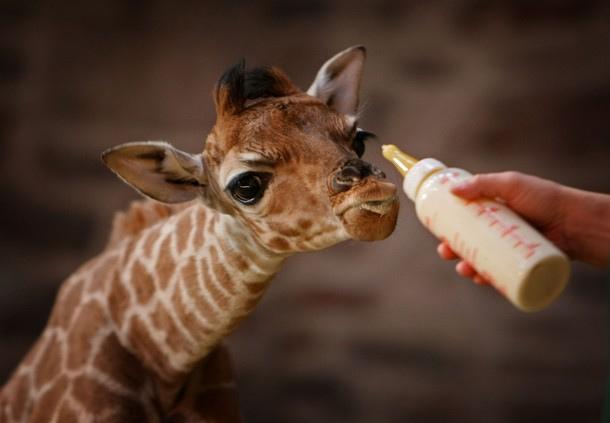What are they feeding the giraffe with?
Write a very short answer. Bottle. What type of milk is in the bottle?
Write a very short answer. Formula. Is this animal a baby?
Quick response, please. Yes. Is the animal a baby or an adult?
Concise answer only. Baby. 